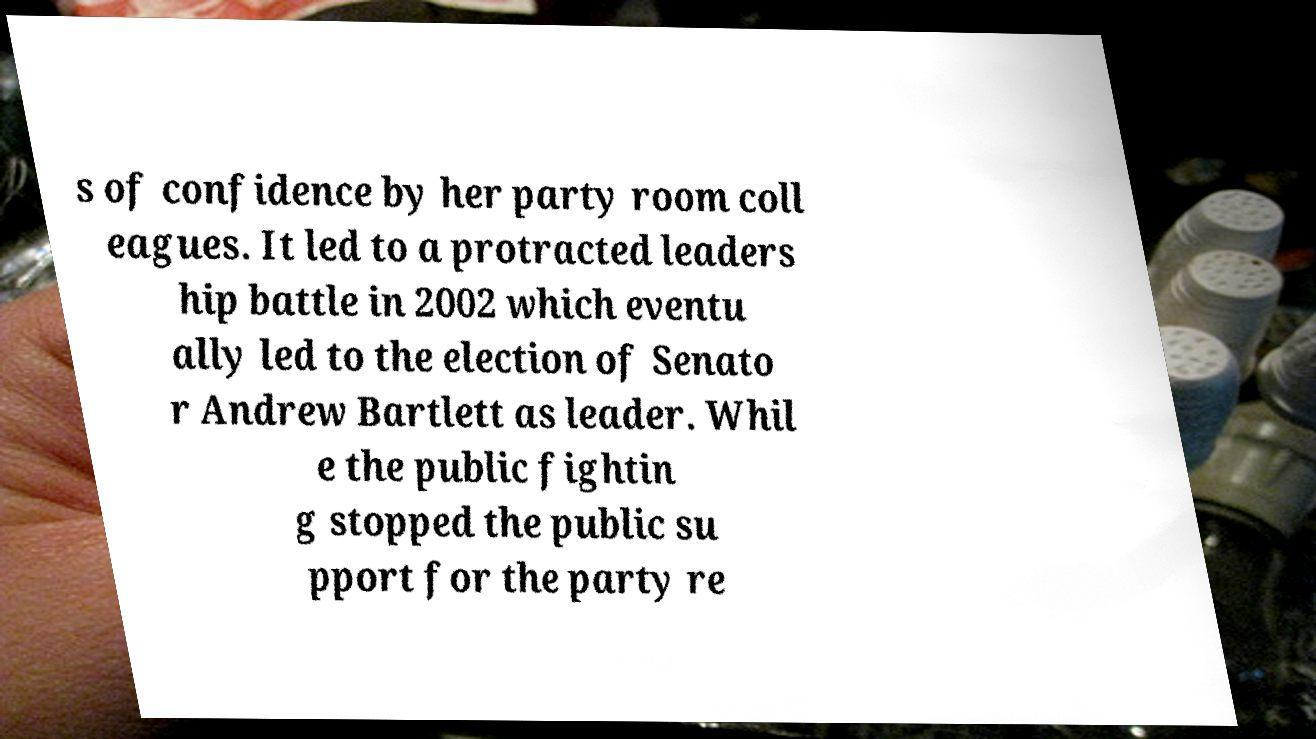Please read and relay the text visible in this image. What does it say? s of confidence by her party room coll eagues. It led to a protracted leaders hip battle in 2002 which eventu ally led to the election of Senato r Andrew Bartlett as leader. Whil e the public fightin g stopped the public su pport for the party re 